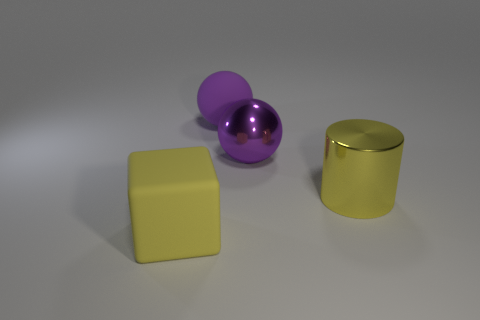There is a thing that is in front of the yellow object that is behind the big yellow thing left of the metallic sphere; how big is it?
Provide a short and direct response. Large. How many other things are the same size as the purple metal sphere?
Keep it short and to the point. 3. What number of big red objects are made of the same material as the big yellow block?
Offer a very short reply. 0. The yellow object that is in front of the yellow cylinder has what shape?
Your answer should be compact. Cube. Is the cube made of the same material as the large yellow object to the right of the rubber block?
Offer a terse response. No. Are any cyan matte cylinders visible?
Your answer should be very brief. No. There is a large rubber thing that is behind the purple sphere on the right side of the large purple rubber object; are there any large spheres in front of it?
Offer a very short reply. Yes. How many big objects are either yellow cylinders or matte cubes?
Keep it short and to the point. 2. What color is the metal object that is the same size as the metallic sphere?
Make the answer very short. Yellow. What number of large things are behind the large purple shiny ball?
Keep it short and to the point. 1. 